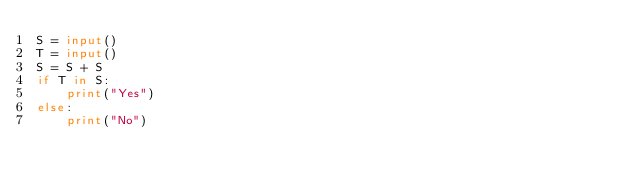Convert code to text. <code><loc_0><loc_0><loc_500><loc_500><_Python_>S = input()
T = input()
S = S + S
if T in S:
    print("Yes")
else:
    print("No")
</code> 